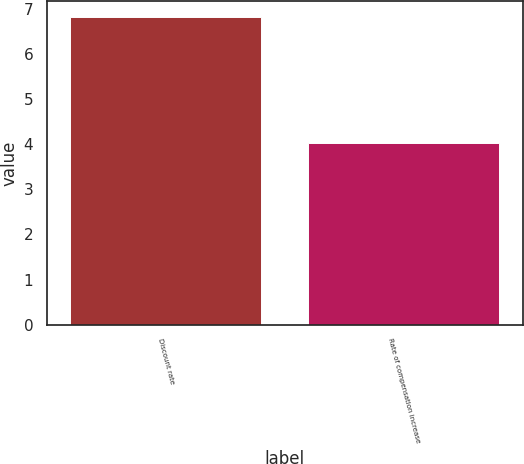<chart> <loc_0><loc_0><loc_500><loc_500><bar_chart><fcel>Discount rate<fcel>Rate of compensation increase<nl><fcel>6.82<fcel>4.03<nl></chart> 